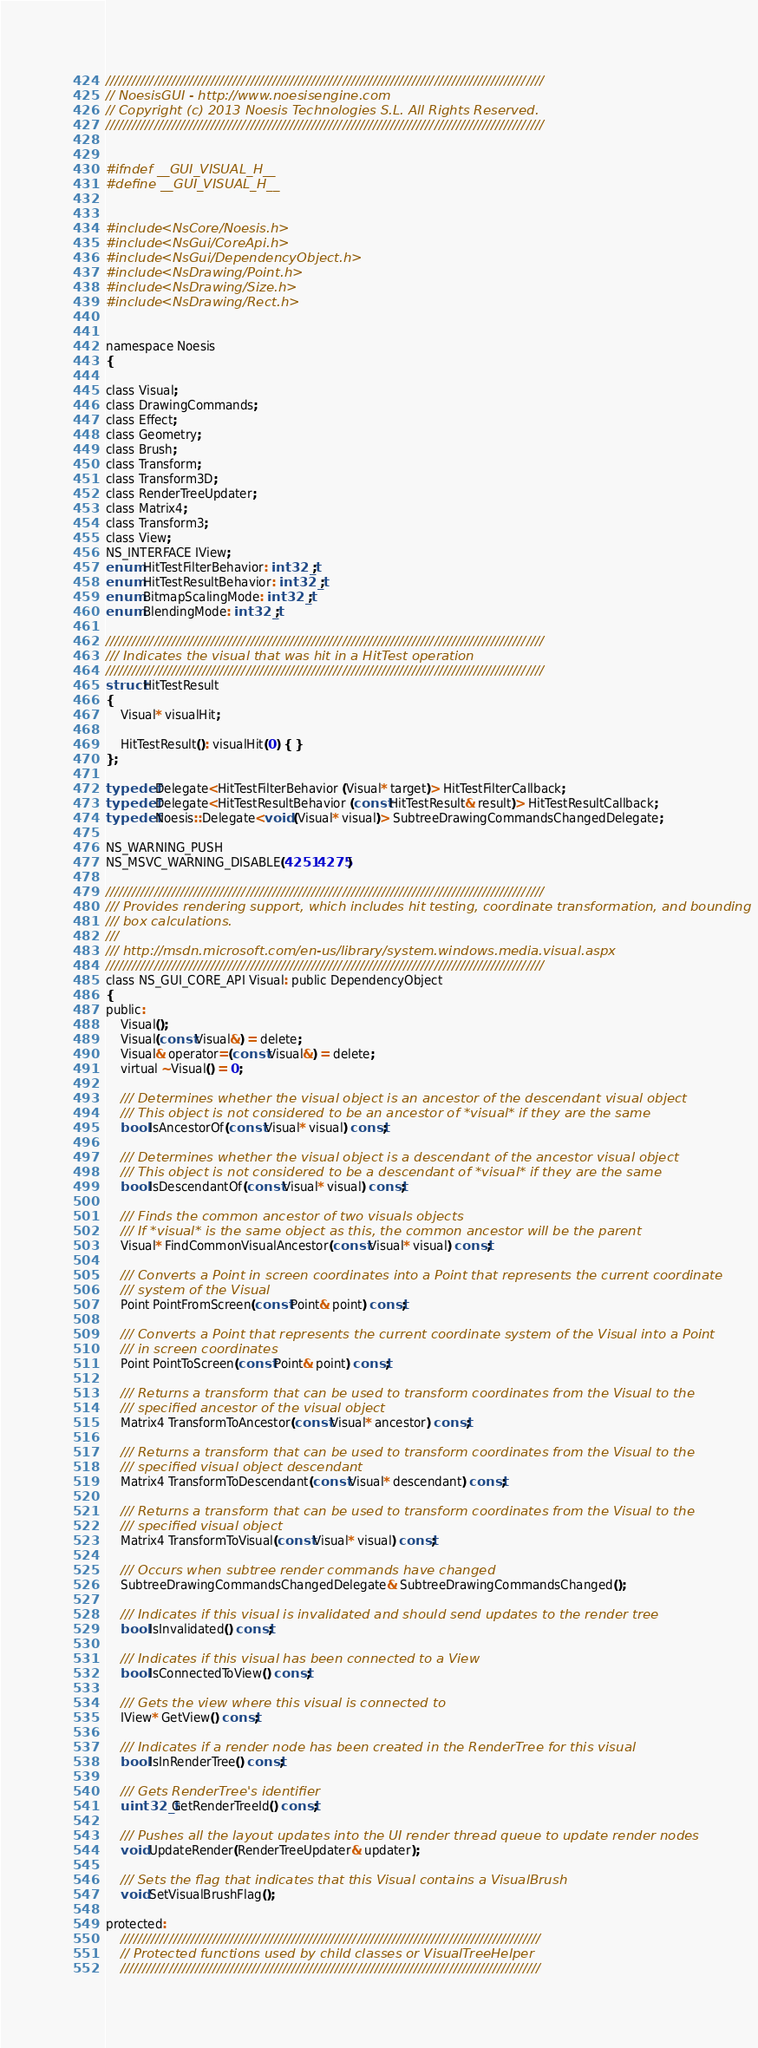Convert code to text. <code><loc_0><loc_0><loc_500><loc_500><_C_>////////////////////////////////////////////////////////////////////////////////////////////////////
// NoesisGUI - http://www.noesisengine.com
// Copyright (c) 2013 Noesis Technologies S.L. All Rights Reserved.
////////////////////////////////////////////////////////////////////////////////////////////////////


#ifndef __GUI_VISUAL_H__
#define __GUI_VISUAL_H__


#include <NsCore/Noesis.h>
#include <NsGui/CoreApi.h>
#include <NsGui/DependencyObject.h>
#include <NsDrawing/Point.h>
#include <NsDrawing/Size.h>
#include <NsDrawing/Rect.h>


namespace Noesis
{

class Visual;
class DrawingCommands;
class Effect;
class Geometry;
class Brush;
class Transform;
class Transform3D;
class RenderTreeUpdater;
class Matrix4;
class Transform3;
class View;
NS_INTERFACE IView;
enum HitTestFilterBehavior: int32_t;
enum HitTestResultBehavior: int32_t;
enum BitmapScalingMode: int32_t;
enum BlendingMode: int32_t;

////////////////////////////////////////////////////////////////////////////////////////////////////
/// Indicates the visual that was hit in a HitTest operation
////////////////////////////////////////////////////////////////////////////////////////////////////
struct HitTestResult
{
    Visual* visualHit;

    HitTestResult(): visualHit(0) { }
};

typedef Delegate<HitTestFilterBehavior (Visual* target)> HitTestFilterCallback;
typedef Delegate<HitTestResultBehavior (const HitTestResult& result)> HitTestResultCallback;
typedef Noesis::Delegate<void (Visual* visual)> SubtreeDrawingCommandsChangedDelegate;

NS_WARNING_PUSH
NS_MSVC_WARNING_DISABLE(4251 4275)

////////////////////////////////////////////////////////////////////////////////////////////////////
/// Provides rendering support, which includes hit testing, coordinate transformation, and bounding
/// box calculations.
///
/// http://msdn.microsoft.com/en-us/library/system.windows.media.visual.aspx
////////////////////////////////////////////////////////////////////////////////////////////////////
class NS_GUI_CORE_API Visual: public DependencyObject
{
public:
    Visual();
    Visual(const Visual&) = delete;
    Visual& operator=(const Visual&) = delete;
    virtual ~Visual() = 0;

    /// Determines whether the visual object is an ancestor of the descendant visual object
    /// This object is not considered to be an ancestor of *visual* if they are the same
    bool IsAncestorOf(const Visual* visual) const;

    /// Determines whether the visual object is a descendant of the ancestor visual object
    /// This object is not considered to be a descendant of *visual* if they are the same
    bool IsDescendantOf(const Visual* visual) const;

    /// Finds the common ancestor of two visuals objects
    /// If *visual* is the same object as this, the common ancestor will be the parent
    Visual* FindCommonVisualAncestor(const Visual* visual) const;

    /// Converts a Point in screen coordinates into a Point that represents the current coordinate
    /// system of the Visual
    Point PointFromScreen(const Point& point) const;
    
    /// Converts a Point that represents the current coordinate system of the Visual into a Point
    /// in screen coordinates
    Point PointToScreen(const Point& point) const;

    /// Returns a transform that can be used to transform coordinates from the Visual to the
    /// specified ancestor of the visual object
    Matrix4 TransformToAncestor(const Visual* ancestor) const;

    /// Returns a transform that can be used to transform coordinates from the Visual to the
    /// specified visual object descendant
    Matrix4 TransformToDescendant(const Visual* descendant) const;

    /// Returns a transform that can be used to transform coordinates from the Visual to the
    /// specified visual object
    Matrix4 TransformToVisual(const Visual* visual) const;

    /// Occurs when subtree render commands have changed
    SubtreeDrawingCommandsChangedDelegate& SubtreeDrawingCommandsChanged();

    /// Indicates if this visual is invalidated and should send updates to the render tree
    bool IsInvalidated() const;

    /// Indicates if this visual has been connected to a View
    bool IsConnectedToView() const;

    /// Gets the view where this visual is connected to
    IView* GetView() const;

    /// Indicates if a render node has been created in the RenderTree for this visual
    bool IsInRenderTree() const;

    /// Gets RenderTree's identifier
    uint32_t GetRenderTreeId() const;

    /// Pushes all the layout updates into the UI render thread queue to update render nodes
    void UpdateRender(RenderTreeUpdater& updater);

    /// Sets the flag that indicates that this Visual contains a VisualBrush
    void SetVisualBrushFlag();

protected:
    ////////////////////////////////////////////////////////////////////////////////////////////////
    // Protected functions used by child classes or VisualTreeHelper
    ////////////////////////////////////////////////////////////////////////////////////////////////</code> 